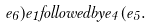<formula> <loc_0><loc_0><loc_500><loc_500>e _ { 6 } ) e _ { 1 } f o l l o w e d b y e _ { 4 } ( e _ { 5 } .</formula> 